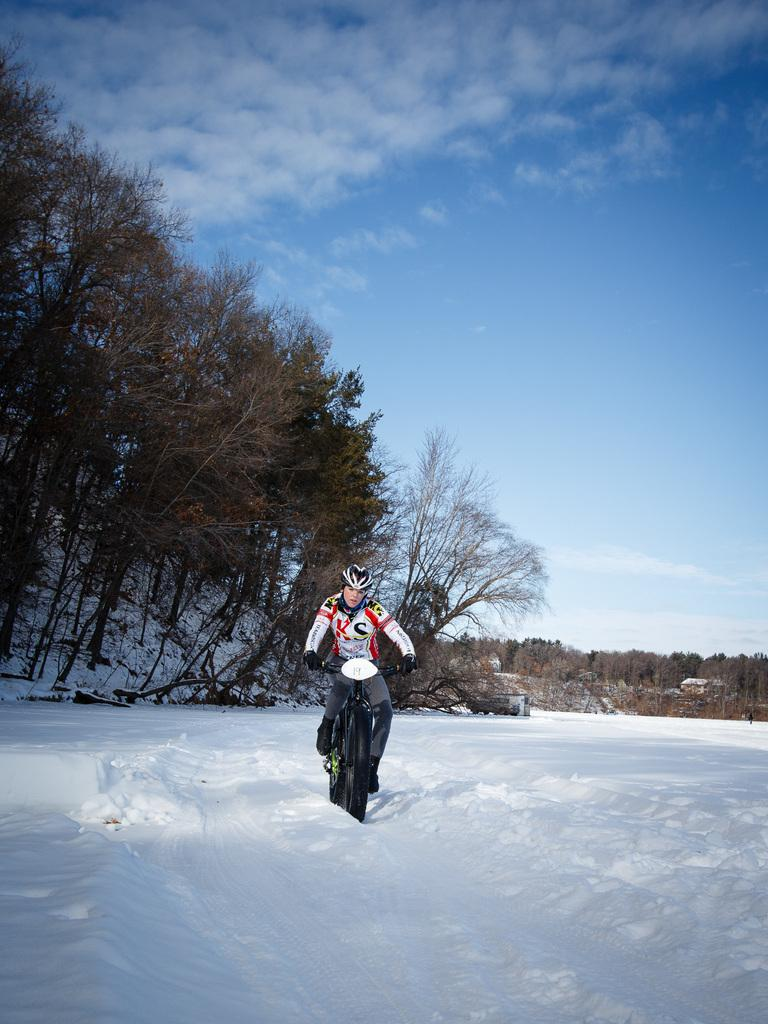What activity is the person in the image engaged in? The person is riding a bicycle. What type of terrain is the person riding on? The person is on snow. What safety gear is the person wearing? The person is wearing a helmet. What clothing is the person wearing to protect against the cold? The person is wearing a jacket. What can be seen in the background of the image? There are trees behind the person. Can you see any waves in the image? There are no waves present in the image; it features a person riding a bicycle on snow. What type of berry is the person holding while riding the bicycle? There is no berry present in the image; the person is wearing a helmet and jacket while riding a bicycle on snow. 